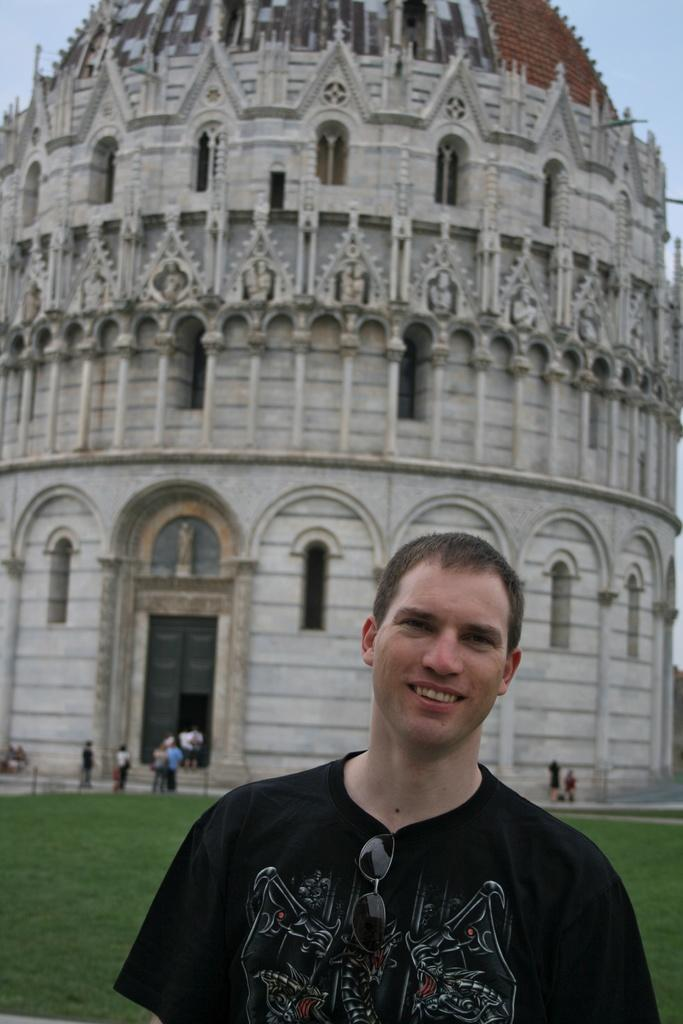Who is present in the image? There is a man in the image. What is the man doing in the image? The man is smiling in the image. What is the man wearing in the image? The man is wearing a black shirt in the image. What can be seen in the background of the image? There is a tower and people visible in the background of the image. What is visible at the top of the image? The sky is visible at the top of the image. What type of stove can be seen in the image? There is no stove present in the image. Are there any bears visible in the image? There are no bears present in the image. 